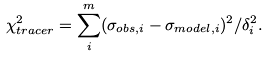Convert formula to latex. <formula><loc_0><loc_0><loc_500><loc_500>\chi ^ { 2 } _ { t r a c e r } = \sum _ { i } ^ { m } ( \sigma _ { o b s , i } - \sigma _ { m o d e l , i } ) ^ { 2 } / \delta _ { i } ^ { 2 } .</formula> 